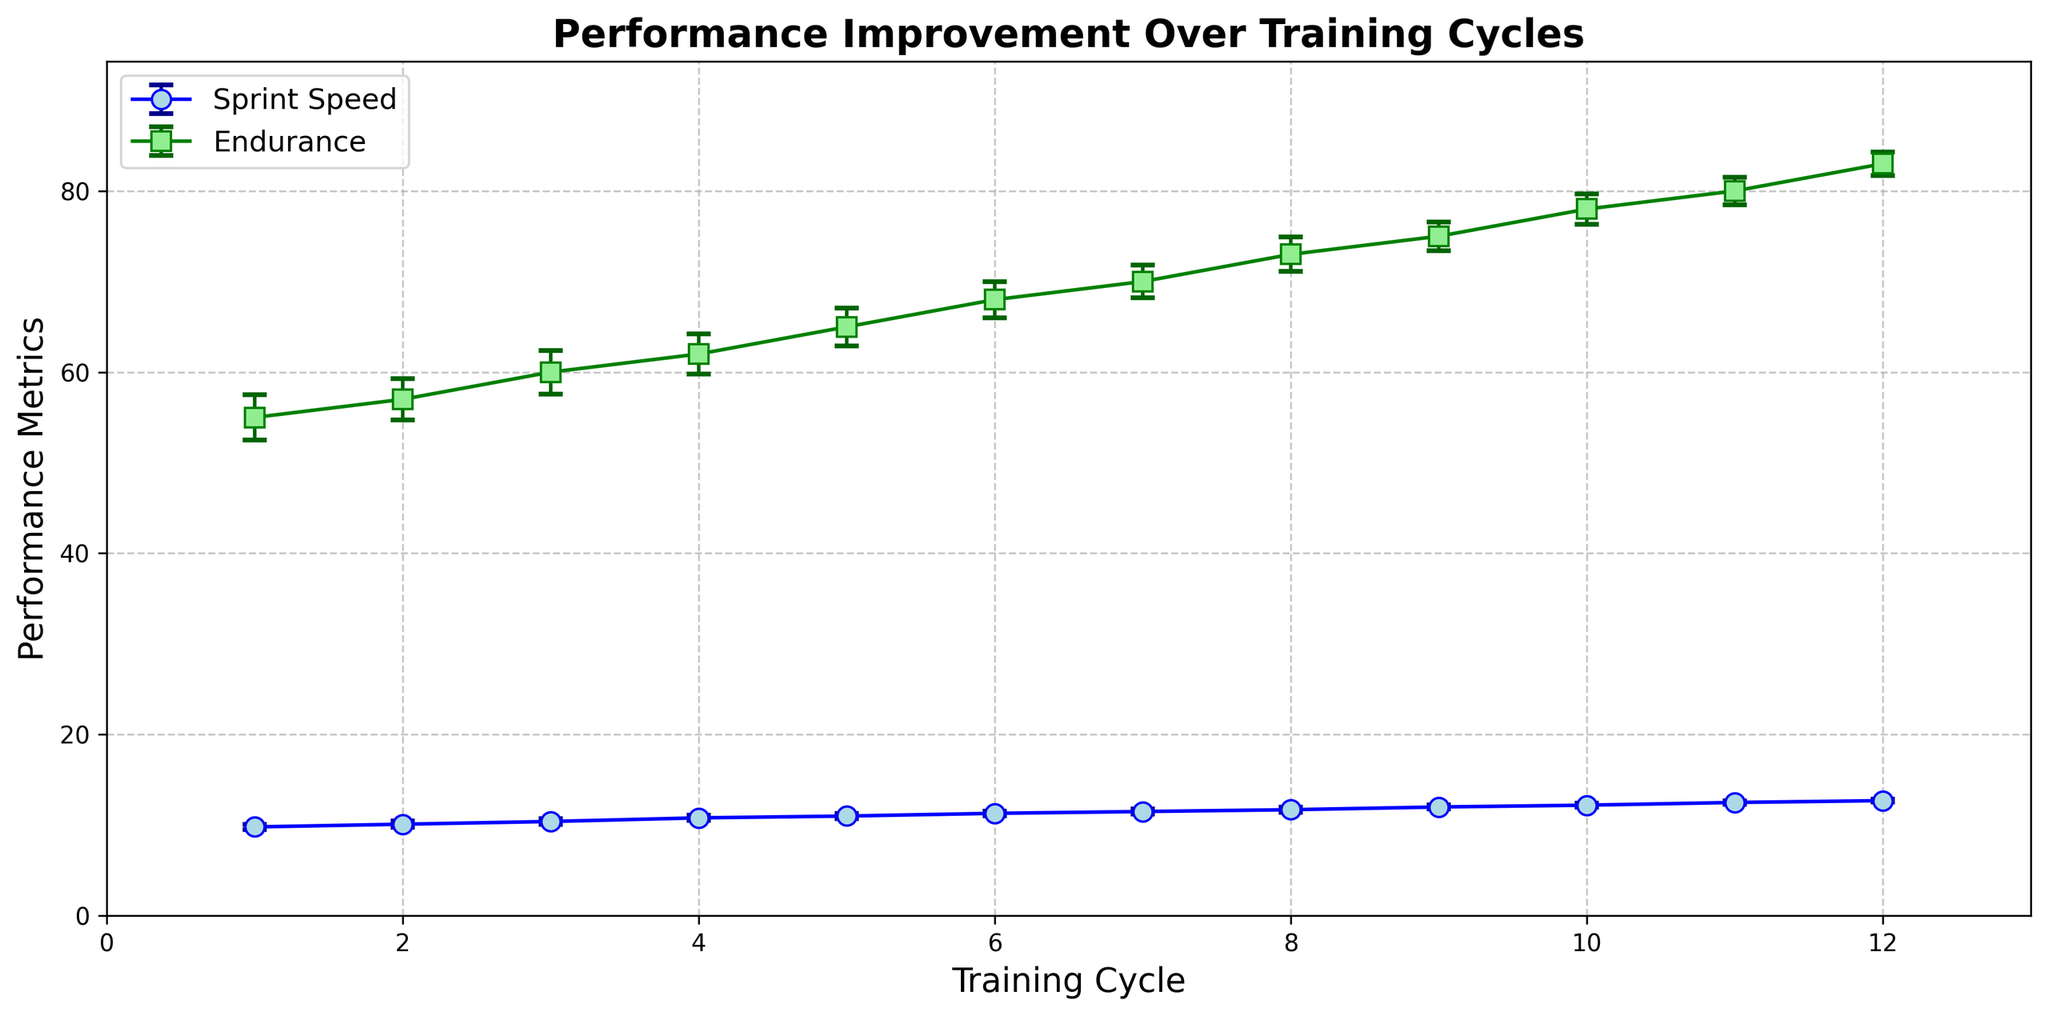What is the highest Sprint Speed recorded across all training cycles? The highest Sprint Speed value is the maximum point on the Sprint Speed line on the graph. By examining the plot, the maximum Sprint Speed recorded is at the 12th training cycle, which is 12.7.
Answer: 12.7 How does the error margin of Sprint Speed in the 5th training cycle compare to the 10th training cycle? The error margin for Sprint Speed in the 5th cycle is the vertical line representing the standard deviation, which is 0.28. For the 10th cycle, the error margin is 0.22. Comparing these, 0.28 is greater than 0.22.
Answer: 0.28 is greater What is the percentage increase in Sprint Speed from the 1st to the 12th training cycle? Calculate the percentage increase using the formula [(New Value - Old Value) / Old Value] * 100. The values are 12.7 and 9.8. [(12.7 - 9.8) / 9.8] * 100 = 29.59%.
Answer: 29.59% During which training cycle does Endurance show the smallest error margin? Error margins are shown as vertical lines. The smallest error margin is observed when the vertical line is shortest. The shortest error margin for Endurance is in the 12th training cycle, which is 1.3.
Answer: 12th training cycle What is the improvement in Endurance from the 6th to the 9th training cycle? Improvement is the difference in Endurance means between the 6th and 9th cycles. These values are 68 and 75, respectively. The improvement is 75 - 68 = 7.
Answer: 7 Which has a higher average error margin, Sprint Speed or Endurance? Calculate the average error by summing all standard deviations and dividing by the number of cycles. For Sprint Speed: (0.3 + 0.35 + 0.32 + 0.3 + 0.28 + 0.25 + 0.27 + 0.26 + 0.24 + 0.22 + 0.2 + 0.18) / 12 ≈ 0.273. For Endurance: (2.5 + 2.3 + 2.4 + 2.2 + 2.1 + 2.0 + 1.8 + 1.9 + 1.6 + 1.7 + 1.5 + 1.3) / 12 ≈ 1.925. Comparing these, 1.925 is greater than 0.273.
Answer: Endurance During which training cycle is the difference between Sprint Speed and Endurance the greatest? Calculate the difference for each cycle and find the maximum. Differences: 1: (55 - 9.8), 2: (57 - 10.1), ..., 12: (83 - 12.7). The greatest difference is at the 12th cycle: 83 - 12.7 = 70.3.
Answer: 12th training cycle What is the trend in Endurance from training cycle 4 to 7? Observe the plot for Endurance from cycle 4 to 7. The values increase from 62 to 70, indicating an upward trend.
Answer: Upward trend Which metric shows a steadier improvement over training cycles based on visual inspection of error margins? Observe the consistency of error margins. Sprint Speed error margins show less variability (are more stable) compared to Endurance.
Answer: Sprint Speed 